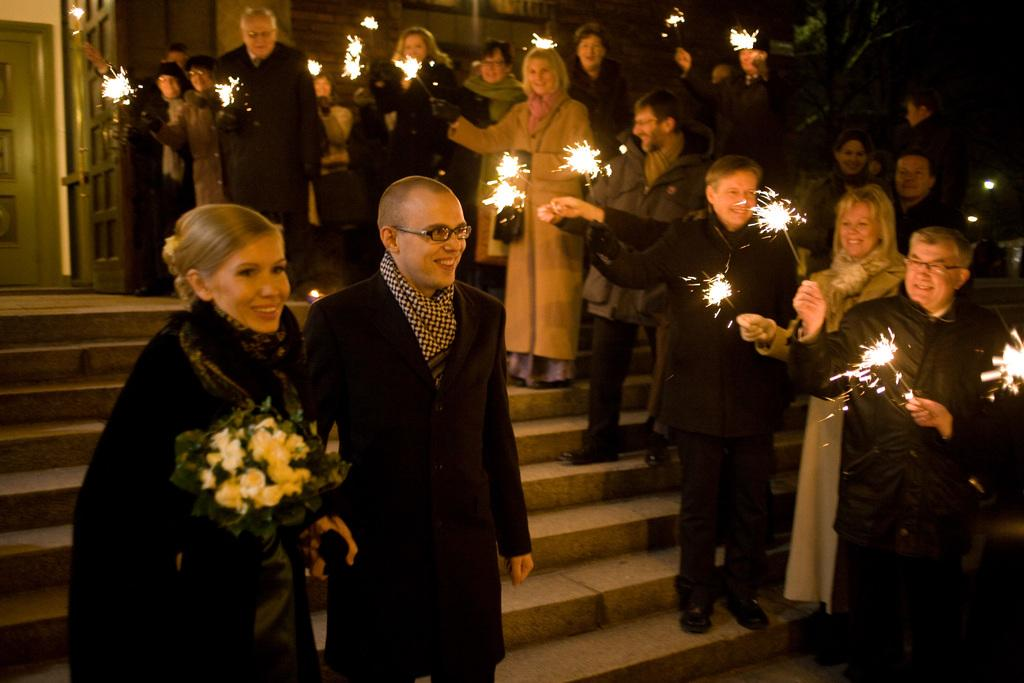How many people are in the image? There is a group of people in the image. What are the people in the image doing? The people are standing and holding fireworks. Is there anyone in the image holding something other than fireworks? Yes, there is a person in front holding a bouquet. What can be seen in the background of the image? There are two doors in the background of the image. What type of trucks can be seen in the image? There are no trucks present in the image. How does the experience of holding fireworks feel for the people in the image? The image does not provide information about the people's feelings or experiences, so we cannot answer this question. 